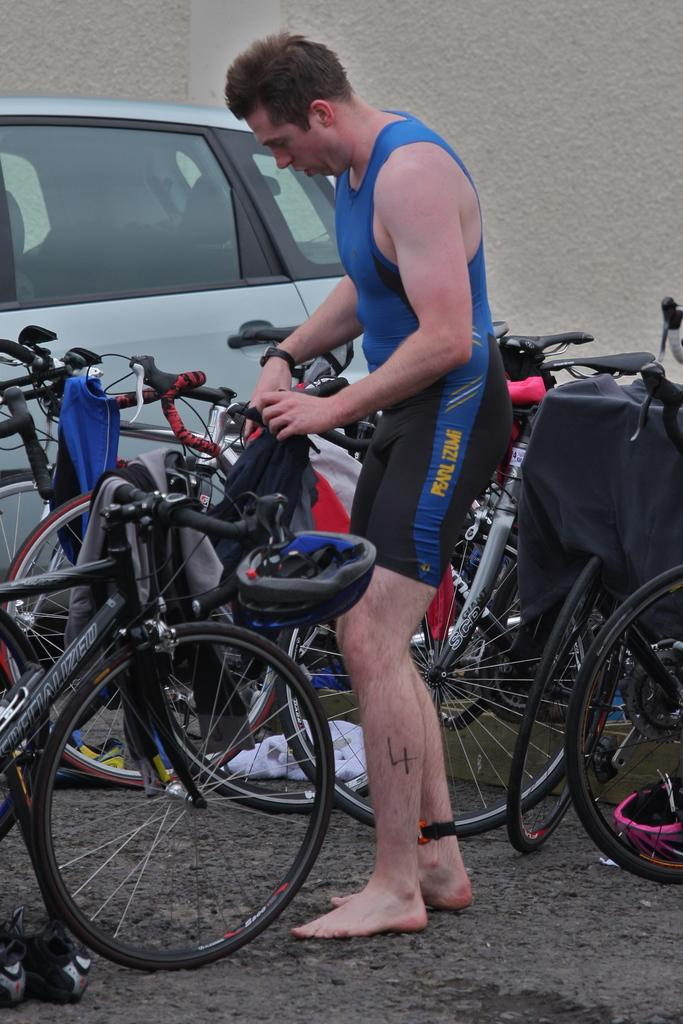What is the person in the image doing? The person is standing on a path in the image. What is the person holding in the image? The person is holding a black object. What type of transportation can be seen in the image? There are bicycles and a vehicle in the image. What else can be seen in the image besides the person and transportation? There are other objects in the image. What is visible in the background of the image? There is a wall in the background of the image. What type of ring is the minister wearing in the image? There is no minister or ring present in the image. 